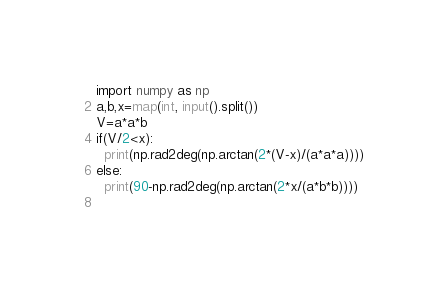Convert code to text. <code><loc_0><loc_0><loc_500><loc_500><_Python_>import numpy as np
a,b,x=map(int, input().split())
V=a*a*b
if(V/2<x):
  print(np.rad2deg(np.arctan(2*(V-x)/(a*a*a))))
else:
  print(90-np.rad2deg(np.arctan(2*x/(a*b*b))))
  </code> 